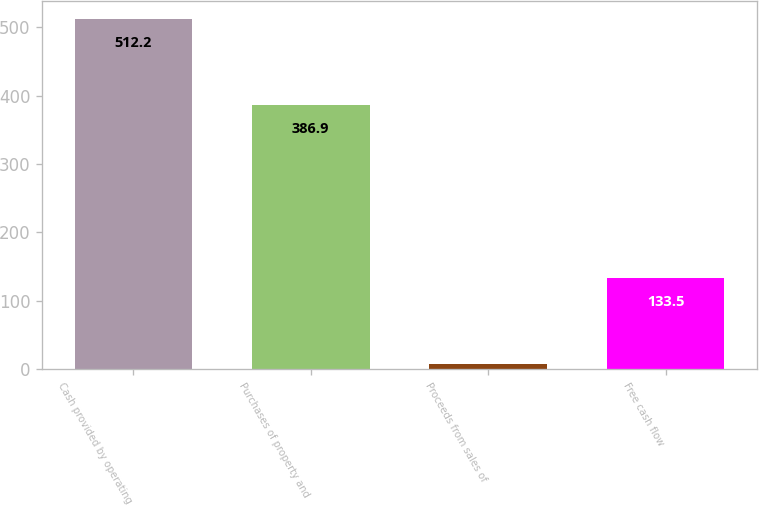<chart> <loc_0><loc_0><loc_500><loc_500><bar_chart><fcel>Cash provided by operating<fcel>Purchases of property and<fcel>Proceeds from sales of<fcel>Free cash flow<nl><fcel>512.2<fcel>386.9<fcel>8.2<fcel>133.5<nl></chart> 